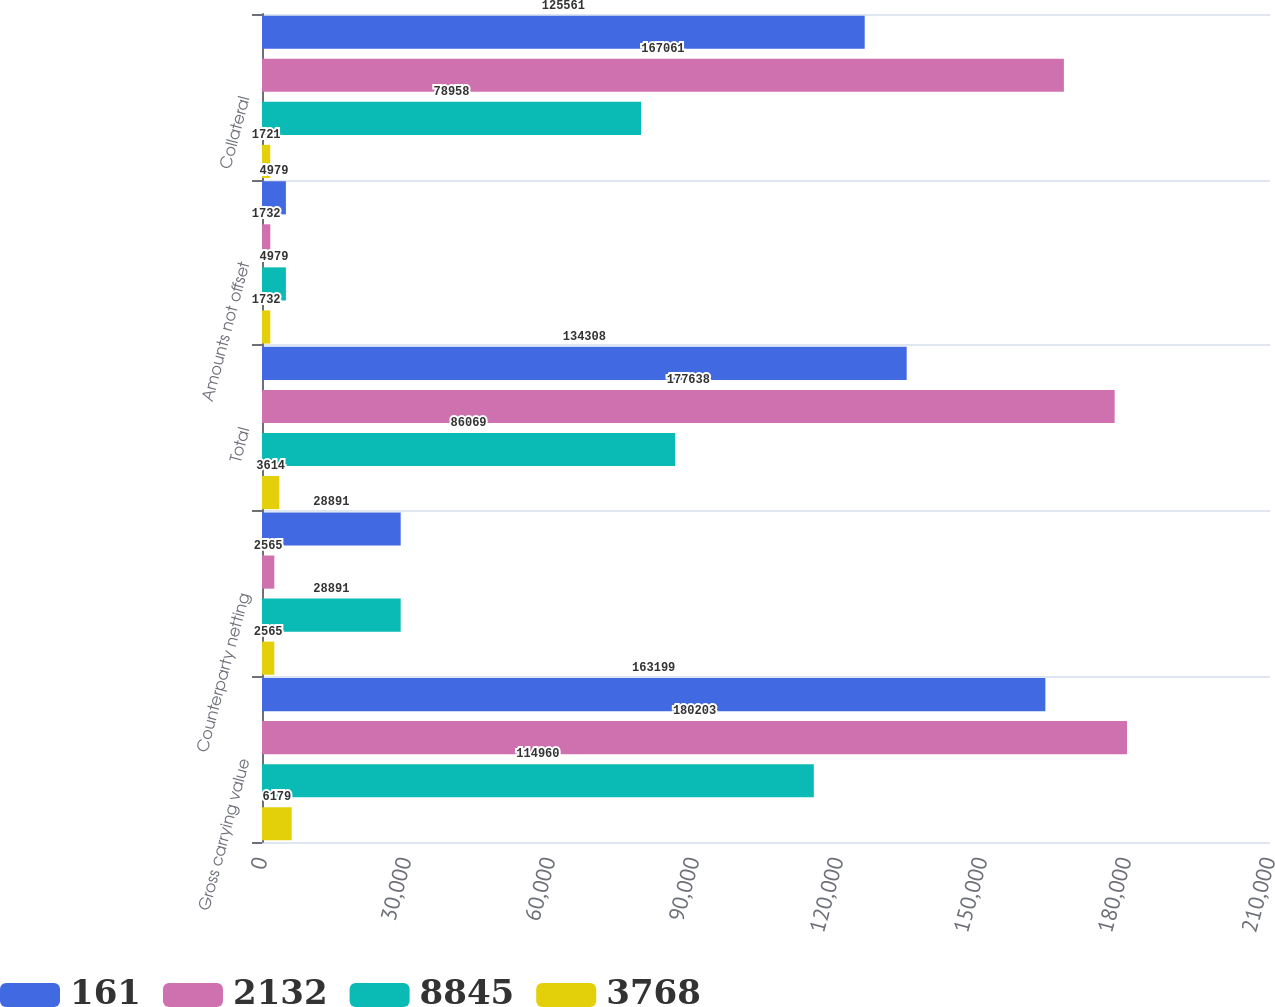Convert chart to OTSL. <chart><loc_0><loc_0><loc_500><loc_500><stacked_bar_chart><ecel><fcel>Gross carrying value<fcel>Counterparty netting<fcel>Total<fcel>Amounts not offset<fcel>Collateral<nl><fcel>161<fcel>163199<fcel>28891<fcel>134308<fcel>4979<fcel>125561<nl><fcel>2132<fcel>180203<fcel>2565<fcel>177638<fcel>1732<fcel>167061<nl><fcel>8845<fcel>114960<fcel>28891<fcel>86069<fcel>4979<fcel>78958<nl><fcel>3768<fcel>6179<fcel>2565<fcel>3614<fcel>1732<fcel>1721<nl></chart> 